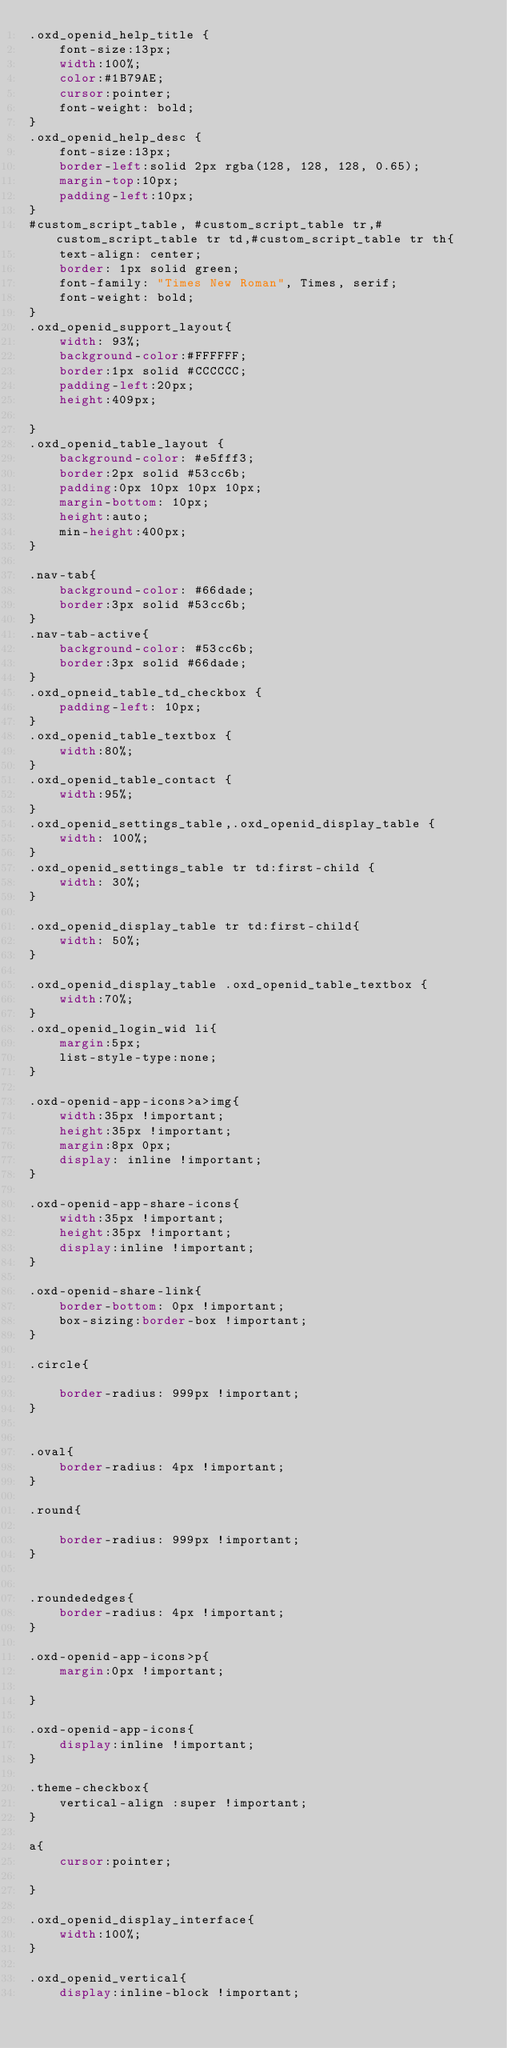<code> <loc_0><loc_0><loc_500><loc_500><_CSS_>.oxd_openid_help_title {
	font-size:13px;
	width:100%;
	color:#1B79AE;
	cursor:pointer;
	font-weight: bold;
}
.oxd_openid_help_desc {
	font-size:13px;
	border-left:solid 2px rgba(128, 128, 128, 0.65);
	margin-top:10px;
	padding-left:10px;
}
#custom_script_table, #custom_script_table tr,#custom_script_table tr td,#custom_script_table tr th{
	text-align: center;
	border: 1px solid green;
	font-family: "Times New Roman", Times, serif;
	font-weight: bold;
}
.oxd_openid_support_layout{
	width: 93%;
	background-color:#FFFFFF;
	border:1px solid #CCCCCC;
	padding-left:20px;
	height:409px;

}
.oxd_openid_table_layout {
	background-color: #e5fff3;
	border:2px solid #53cc6b;
	padding:0px 10px 10px 10px;
	margin-bottom: 10px;
	height:auto;
	min-height:400px;
}

.nav-tab{
	background-color: #66dade;
	border:3px solid #53cc6b;
}
.nav-tab-active{
	background-color: #53cc6b;
	border:3px solid #66dade;
}
.oxd_opneid_table_td_checkbox {
	padding-left: 10px;
}
.oxd_openid_table_textbox {
	width:80%;
}
.oxd_openid_table_contact {
	width:95%;
}
.oxd_openid_settings_table,.oxd_openid_display_table {
	width: 100%;
}
.oxd_openid_settings_table tr td:first-child {
	width: 30%;
}

.oxd_openid_display_table tr td:first-child{
	width: 50%;
}

.oxd_openid_display_table .oxd_openid_table_textbox {
	width:70%;
}
.oxd_openid_login_wid li{
	margin:5px;
	list-style-type:none;
}

.oxd-openid-app-icons>a>img{
	width:35px !important;
	height:35px !important;
	margin:8px 0px;
	display: inline !important;
}

.oxd-openid-app-share-icons{
	width:35px !important;
	height:35px !important;
	display:inline !important;
}

.oxd-openid-share-link{
	border-bottom: 0px !important;
	box-sizing:border-box !important;
}

.circle{

	border-radius: 999px !important;
}


.oval{
	border-radius: 4px !important;
}

.round{

	border-radius: 999px !important;
}


.roundededges{
	border-radius: 4px !important;
}

.oxd-openid-app-icons>p{
	margin:0px !important;

}

.oxd-openid-app-icons{
	display:inline !important;
}

.theme-checkbox{
	vertical-align :super !important;
}

a{
	cursor:pointer;

}

.oxd_openid_display_interface{
	width:100%;
}

.oxd_openid_vertical{
	display:inline-block !important;</code> 